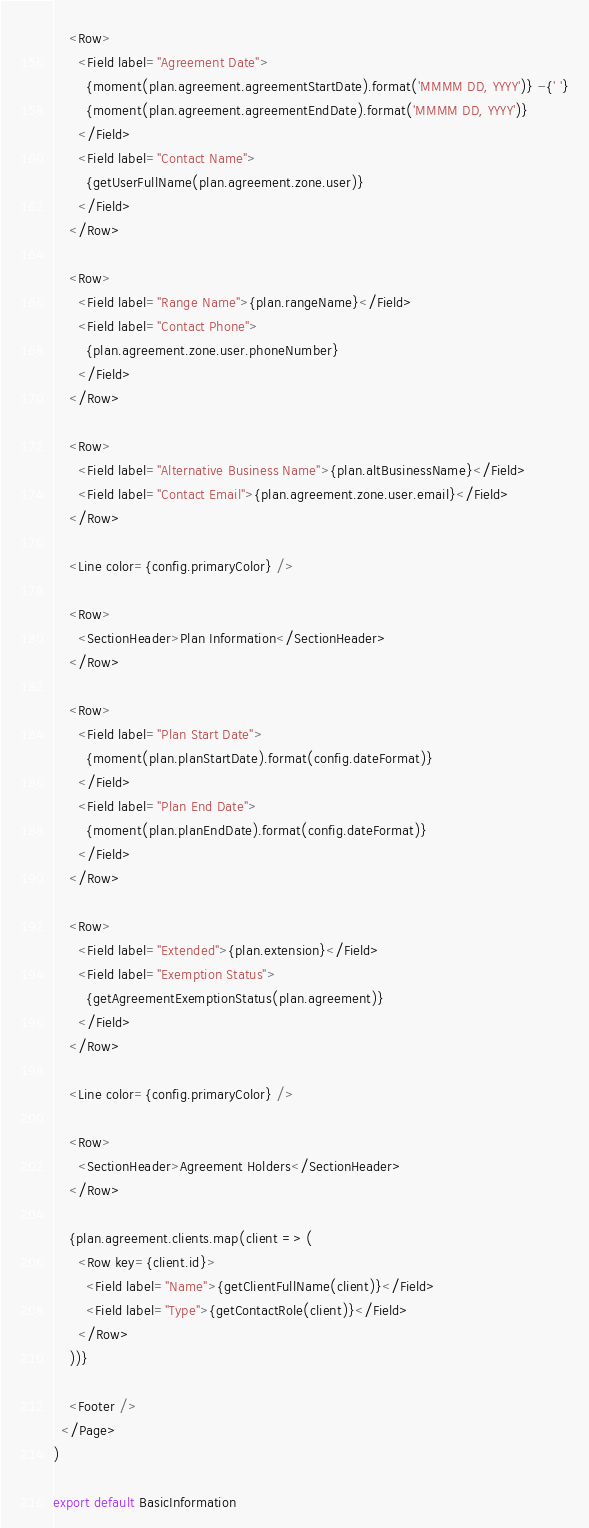<code> <loc_0><loc_0><loc_500><loc_500><_JavaScript_>
    <Row>
      <Field label="Agreement Date">
        {moment(plan.agreement.agreementStartDate).format('MMMM DD, YYYY')} -{' '}
        {moment(plan.agreement.agreementEndDate).format('MMMM DD, YYYY')}
      </Field>
      <Field label="Contact Name">
        {getUserFullName(plan.agreement.zone.user)}
      </Field>
    </Row>

    <Row>
      <Field label="Range Name">{plan.rangeName}</Field>
      <Field label="Contact Phone">
        {plan.agreement.zone.user.phoneNumber}
      </Field>
    </Row>

    <Row>
      <Field label="Alternative Business Name">{plan.altBusinessName}</Field>
      <Field label="Contact Email">{plan.agreement.zone.user.email}</Field>
    </Row>

    <Line color={config.primaryColor} />

    <Row>
      <SectionHeader>Plan Information</SectionHeader>
    </Row>

    <Row>
      <Field label="Plan Start Date">
        {moment(plan.planStartDate).format(config.dateFormat)}
      </Field>
      <Field label="Plan End Date">
        {moment(plan.planEndDate).format(config.dateFormat)}
      </Field>
    </Row>

    <Row>
      <Field label="Extended">{plan.extension}</Field>
      <Field label="Exemption Status">
        {getAgreementExemptionStatus(plan.agreement)}
      </Field>
    </Row>

    <Line color={config.primaryColor} />

    <Row>
      <SectionHeader>Agreement Holders</SectionHeader>
    </Row>

    {plan.agreement.clients.map(client => (
      <Row key={client.id}>
        <Field label="Name">{getClientFullName(client)}</Field>
        <Field label="Type">{getContactRole(client)}</Field>
      </Row>
    ))}

    <Footer />
  </Page>
)

export default BasicInformation
</code> 